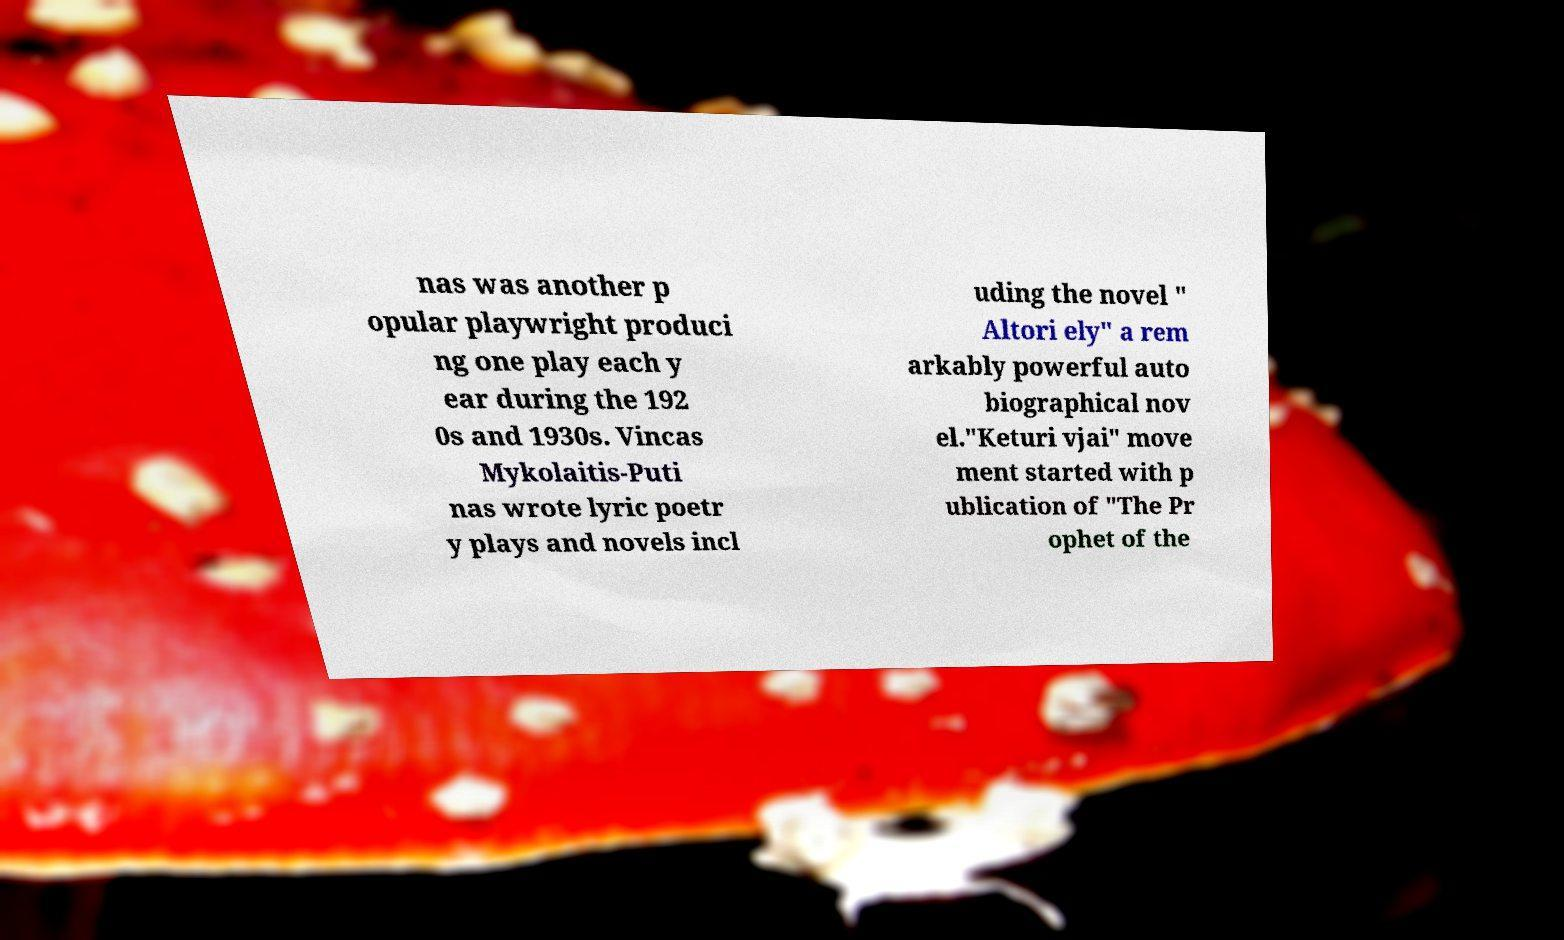There's text embedded in this image that I need extracted. Can you transcribe it verbatim? nas was another p opular playwright produci ng one play each y ear during the 192 0s and 1930s. Vincas Mykolaitis-Puti nas wrote lyric poetr y plays and novels incl uding the novel " Altori ely" a rem arkably powerful auto biographical nov el."Keturi vjai" move ment started with p ublication of "The Pr ophet of the 